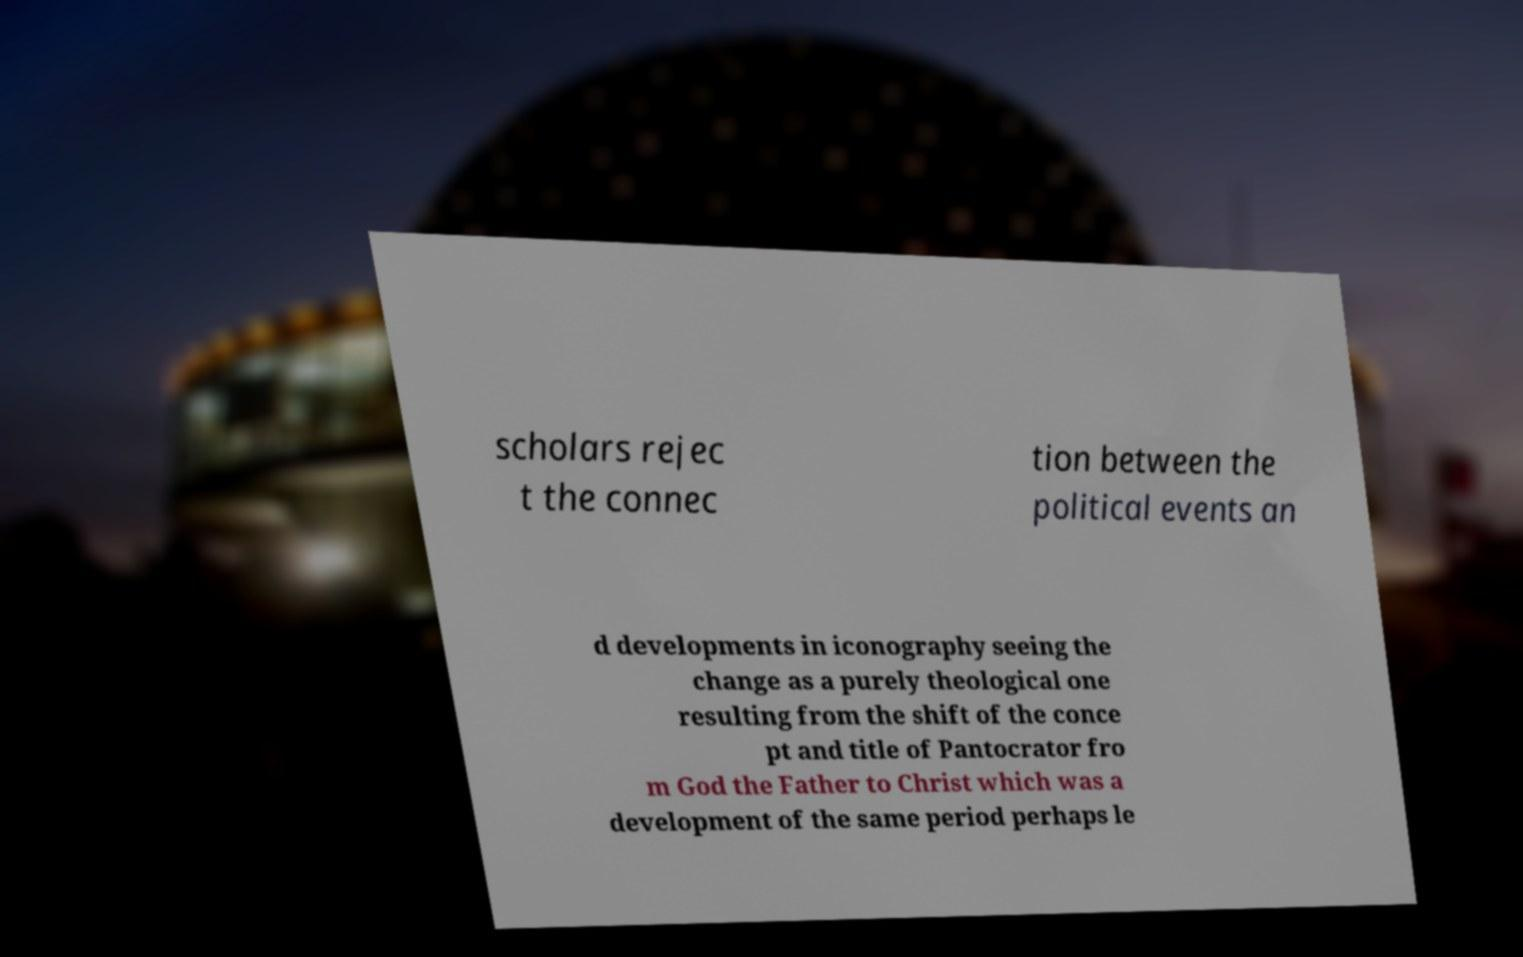Can you read and provide the text displayed in the image?This photo seems to have some interesting text. Can you extract and type it out for me? scholars rejec t the connec tion between the political events an d developments in iconography seeing the change as a purely theological one resulting from the shift of the conce pt and title of Pantocrator fro m God the Father to Christ which was a development of the same period perhaps le 